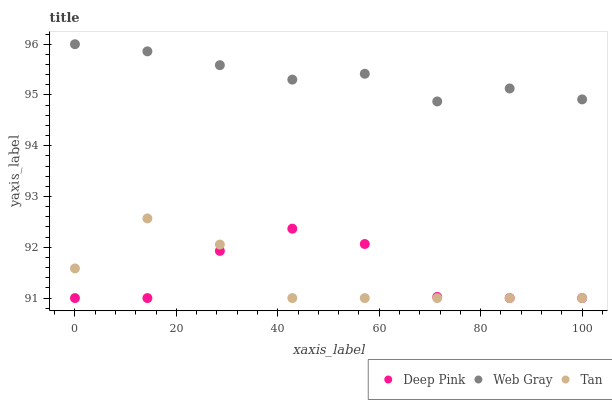Does Tan have the minimum area under the curve?
Answer yes or no. Yes. Does Web Gray have the maximum area under the curve?
Answer yes or no. Yes. Does Deep Pink have the minimum area under the curve?
Answer yes or no. No. Does Deep Pink have the maximum area under the curve?
Answer yes or no. No. Is Web Gray the smoothest?
Answer yes or no. Yes. Is Deep Pink the roughest?
Answer yes or no. Yes. Is Deep Pink the smoothest?
Answer yes or no. No. Is Web Gray the roughest?
Answer yes or no. No. Does Tan have the lowest value?
Answer yes or no. Yes. Does Web Gray have the lowest value?
Answer yes or no. No. Does Web Gray have the highest value?
Answer yes or no. Yes. Does Deep Pink have the highest value?
Answer yes or no. No. Is Deep Pink less than Web Gray?
Answer yes or no. Yes. Is Web Gray greater than Deep Pink?
Answer yes or no. Yes. Does Deep Pink intersect Tan?
Answer yes or no. Yes. Is Deep Pink less than Tan?
Answer yes or no. No. Is Deep Pink greater than Tan?
Answer yes or no. No. Does Deep Pink intersect Web Gray?
Answer yes or no. No. 